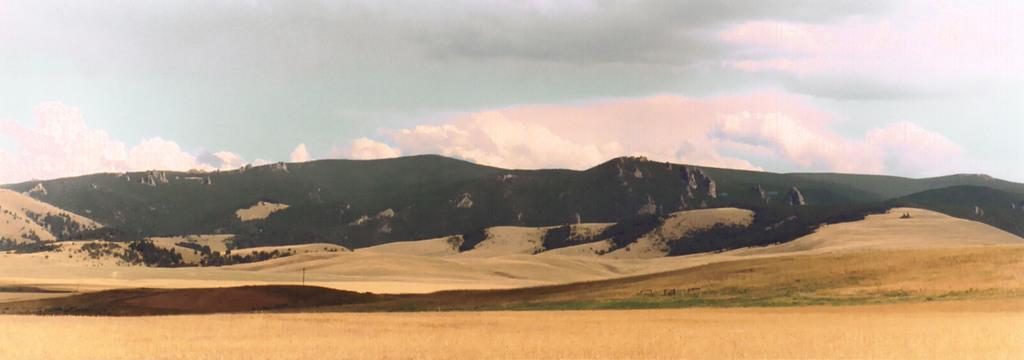Describe this image in one or two sentences. In this picture I can see mountains, trees and a pole. In the background I can see the sky. 